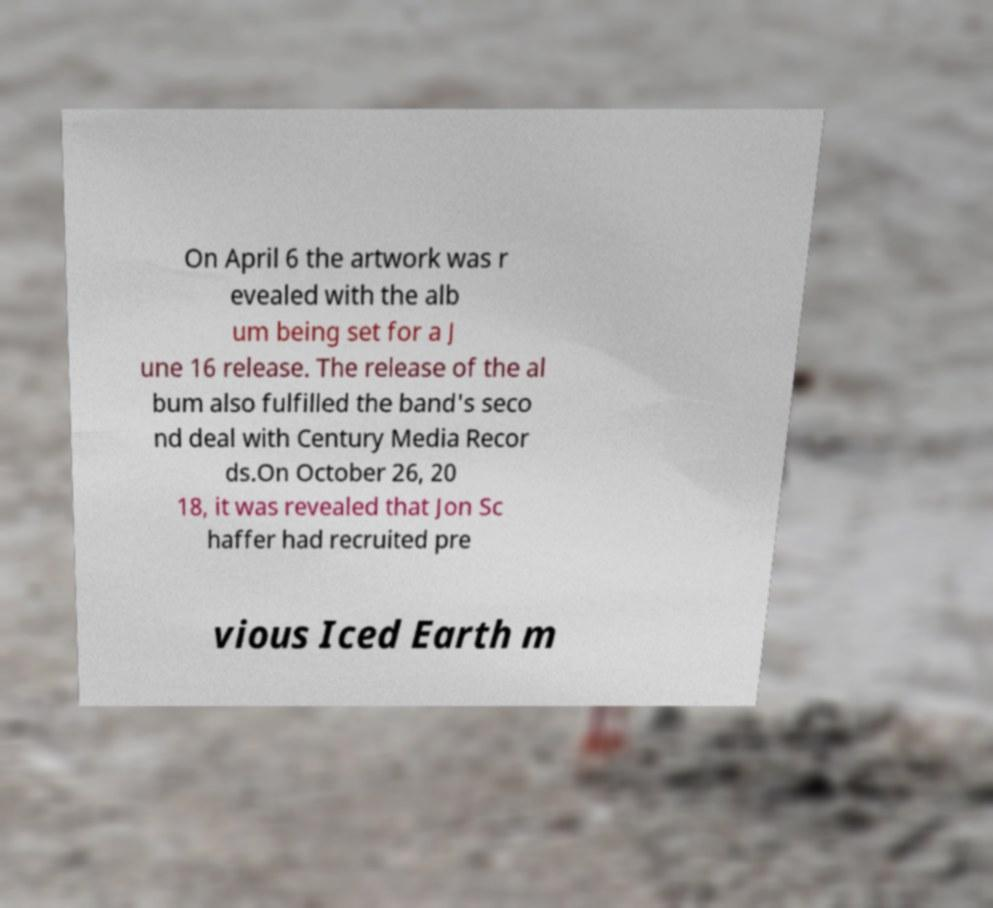For documentation purposes, I need the text within this image transcribed. Could you provide that? On April 6 the artwork was r evealed with the alb um being set for a J une 16 release. The release of the al bum also fulfilled the band's seco nd deal with Century Media Recor ds.On October 26, 20 18, it was revealed that Jon Sc haffer had recruited pre vious Iced Earth m 